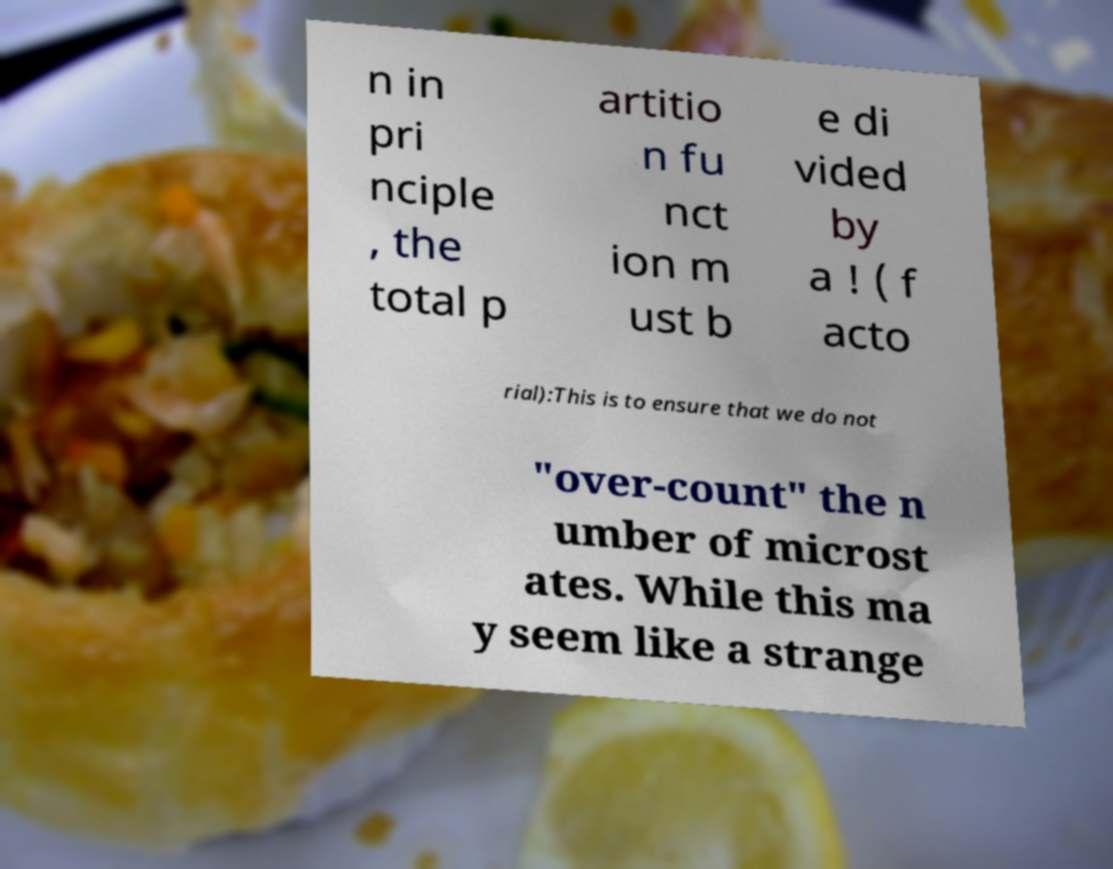Please read and relay the text visible in this image. What does it say? n in pri nciple , the total p artitio n fu nct ion m ust b e di vided by a ! ( f acto rial):This is to ensure that we do not "over-count" the n umber of microst ates. While this ma y seem like a strange 